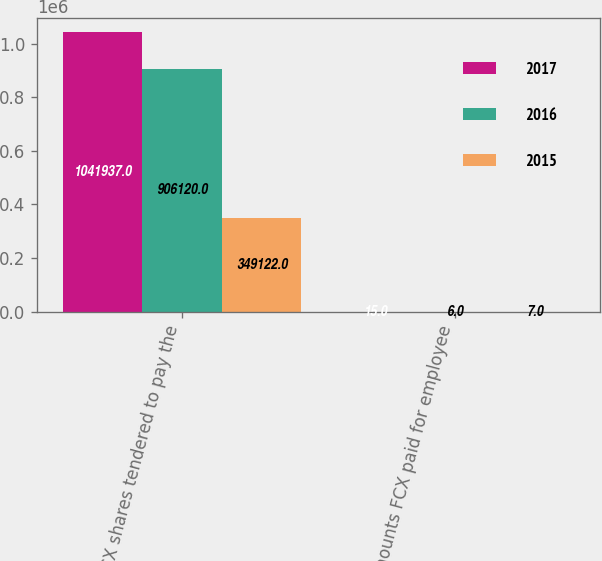Convert chart. <chart><loc_0><loc_0><loc_500><loc_500><stacked_bar_chart><ecel><fcel>FCX shares tendered to pay the<fcel>Amounts FCX paid for employee<nl><fcel>2017<fcel>1.04194e+06<fcel>15<nl><fcel>2016<fcel>906120<fcel>6<nl><fcel>2015<fcel>349122<fcel>7<nl></chart> 